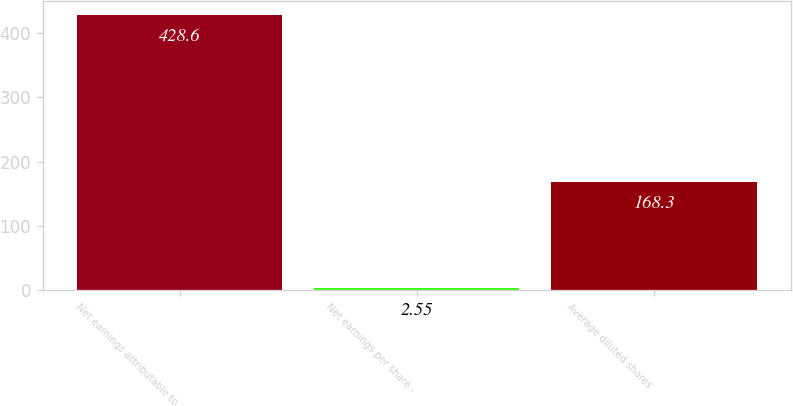Convert chart. <chart><loc_0><loc_0><loc_500><loc_500><bar_chart><fcel>Net earnings attributable to<fcel>Net earnings per share -<fcel>Average diluted shares<nl><fcel>428.6<fcel>2.55<fcel>168.3<nl></chart> 